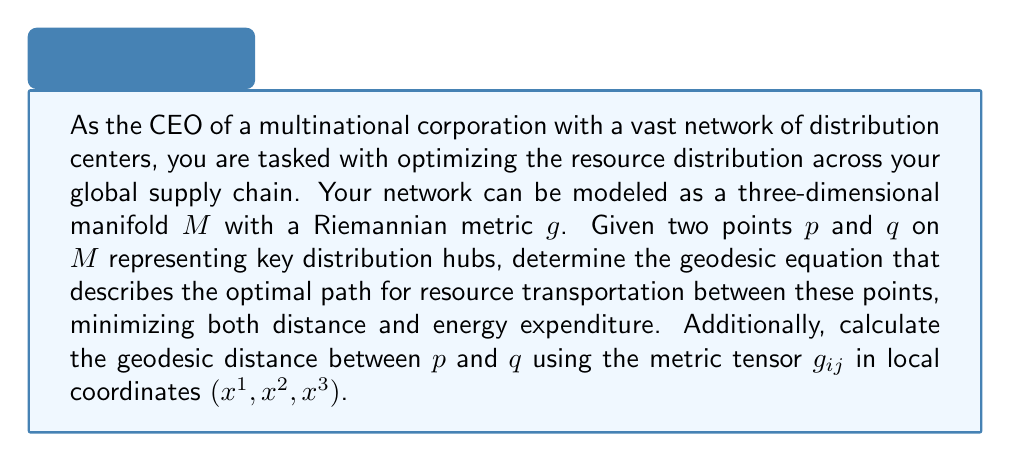Give your solution to this math problem. To solve this problem, we need to follow these steps:

1. Recall the geodesic equation on a Riemannian manifold:
   
   The geodesic equation in local coordinates is given by:

   $$\frac{d^2x^i}{dt^2} + \Gamma^i_{jk}\frac{dx^j}{dt}\frac{dx^k}{dt} = 0$$

   where $\Gamma^i_{jk}$ are the Christoffel symbols of the second kind.

2. Express the Christoffel symbols in terms of the metric tensor:
   
   $$\Gamma^i_{jk} = \frac{1}{2}g^{im}\left(\frac{\partial g_{mj}}{\partial x^k} + \frac{\partial g_{mk}}{\partial x^j} - \frac{\partial g_{jk}}{\partial x^m}\right)$$

   where $g^{im}$ is the inverse of the metric tensor $g_{ij}$.

3. To calculate the geodesic distance between points $p$ and $q$, we use the formula:

   $$d(p,q) = \int_0^1 \sqrt{g_{ij}\frac{dx^i}{dt}\frac{dx^j}{dt}}dt$$

   where $x^i(t)$ represents the geodesic path parametrized by $t \in [0,1]$, with $x^i(0)$ corresponding to $p$ and $x^i(1)$ corresponding to $q$.

4. To solve this integral, we would need to:
   a. Solve the geodesic equation to find $x^i(t)$.
   b. Substitute the solution into the distance formula.
   c. Evaluate the integral from 0 to 1.

The exact solution depends on the specific form of the metric tensor $g_{ij}$ on the manifold $M$, which would be determined by the geographical and logistical constraints of your distribution network.
Answer: The optimal path for resource distribution is described by the geodesic equation:

$$\frac{d^2x^i}{dt^2} + \Gamma^i_{jk}\frac{dx^j}{dt}\frac{dx^k}{dt} = 0$$

where $\Gamma^i_{jk}$ are the Christoffel symbols derived from the metric tensor $g_{ij}$.

The geodesic distance between points $p$ and $q$ is given by:

$$d(p,q) = \int_0^1 \sqrt{g_{ij}\frac{dx^i}{dt}\frac{dx^j}{dt}}dt$$

where $x^i(t)$ is the solution to the geodesic equation with boundary conditions $x^i(0)$ at $p$ and $x^i(1)$ at $q$. 